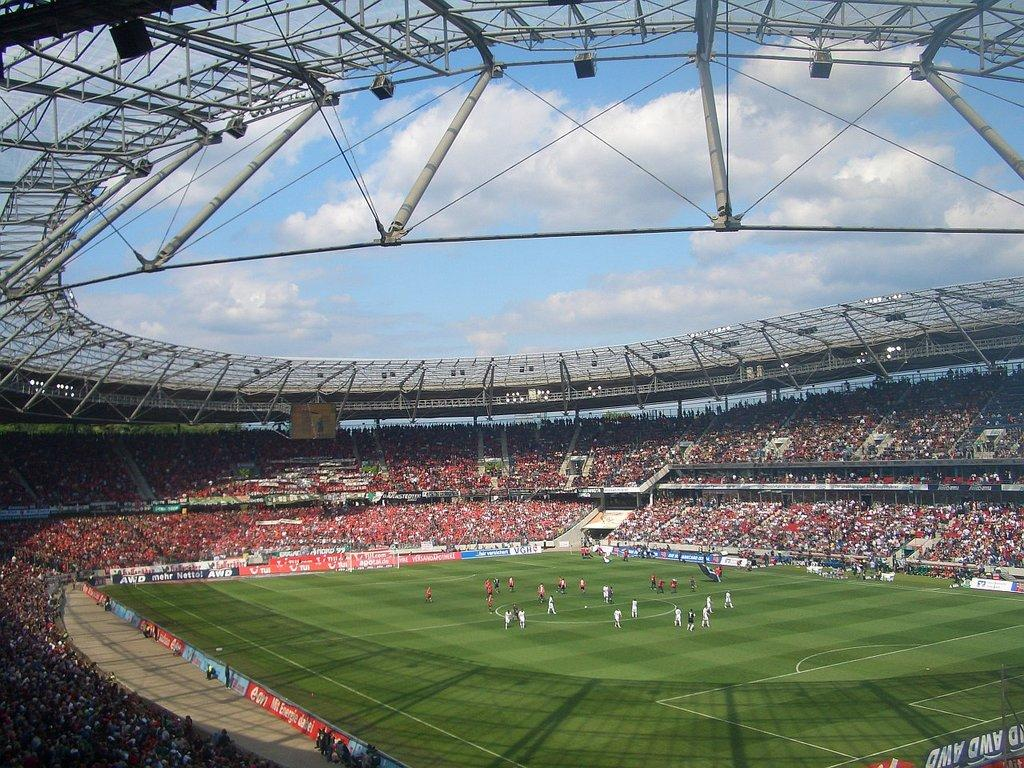What type of structure is shown in the image? There is a stadium in the image. What are the people in the stadium doing? People are sitting on chairs in the stadium. What else can be seen happening in the stadium? There are players on the ground in the stadium. What architectural feature is visible at the top of the image? There is an iron frame visible at the top of the image. How many trees can be seen in the image? There are no trees visible in the image; it features a stadium with people and players. What type of baby is present in the image? There is no baby present in the image. 